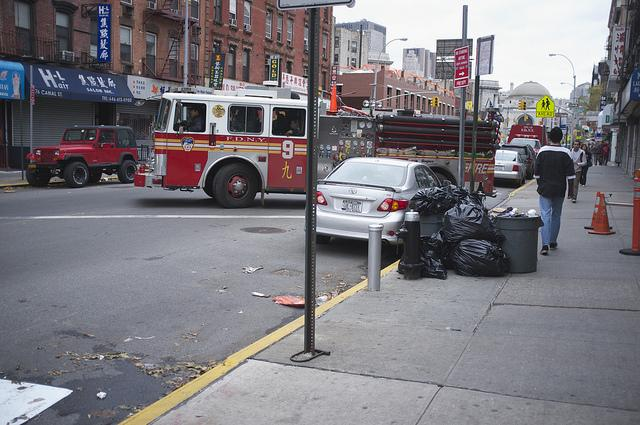For which city does this fire truck perform work? new york 